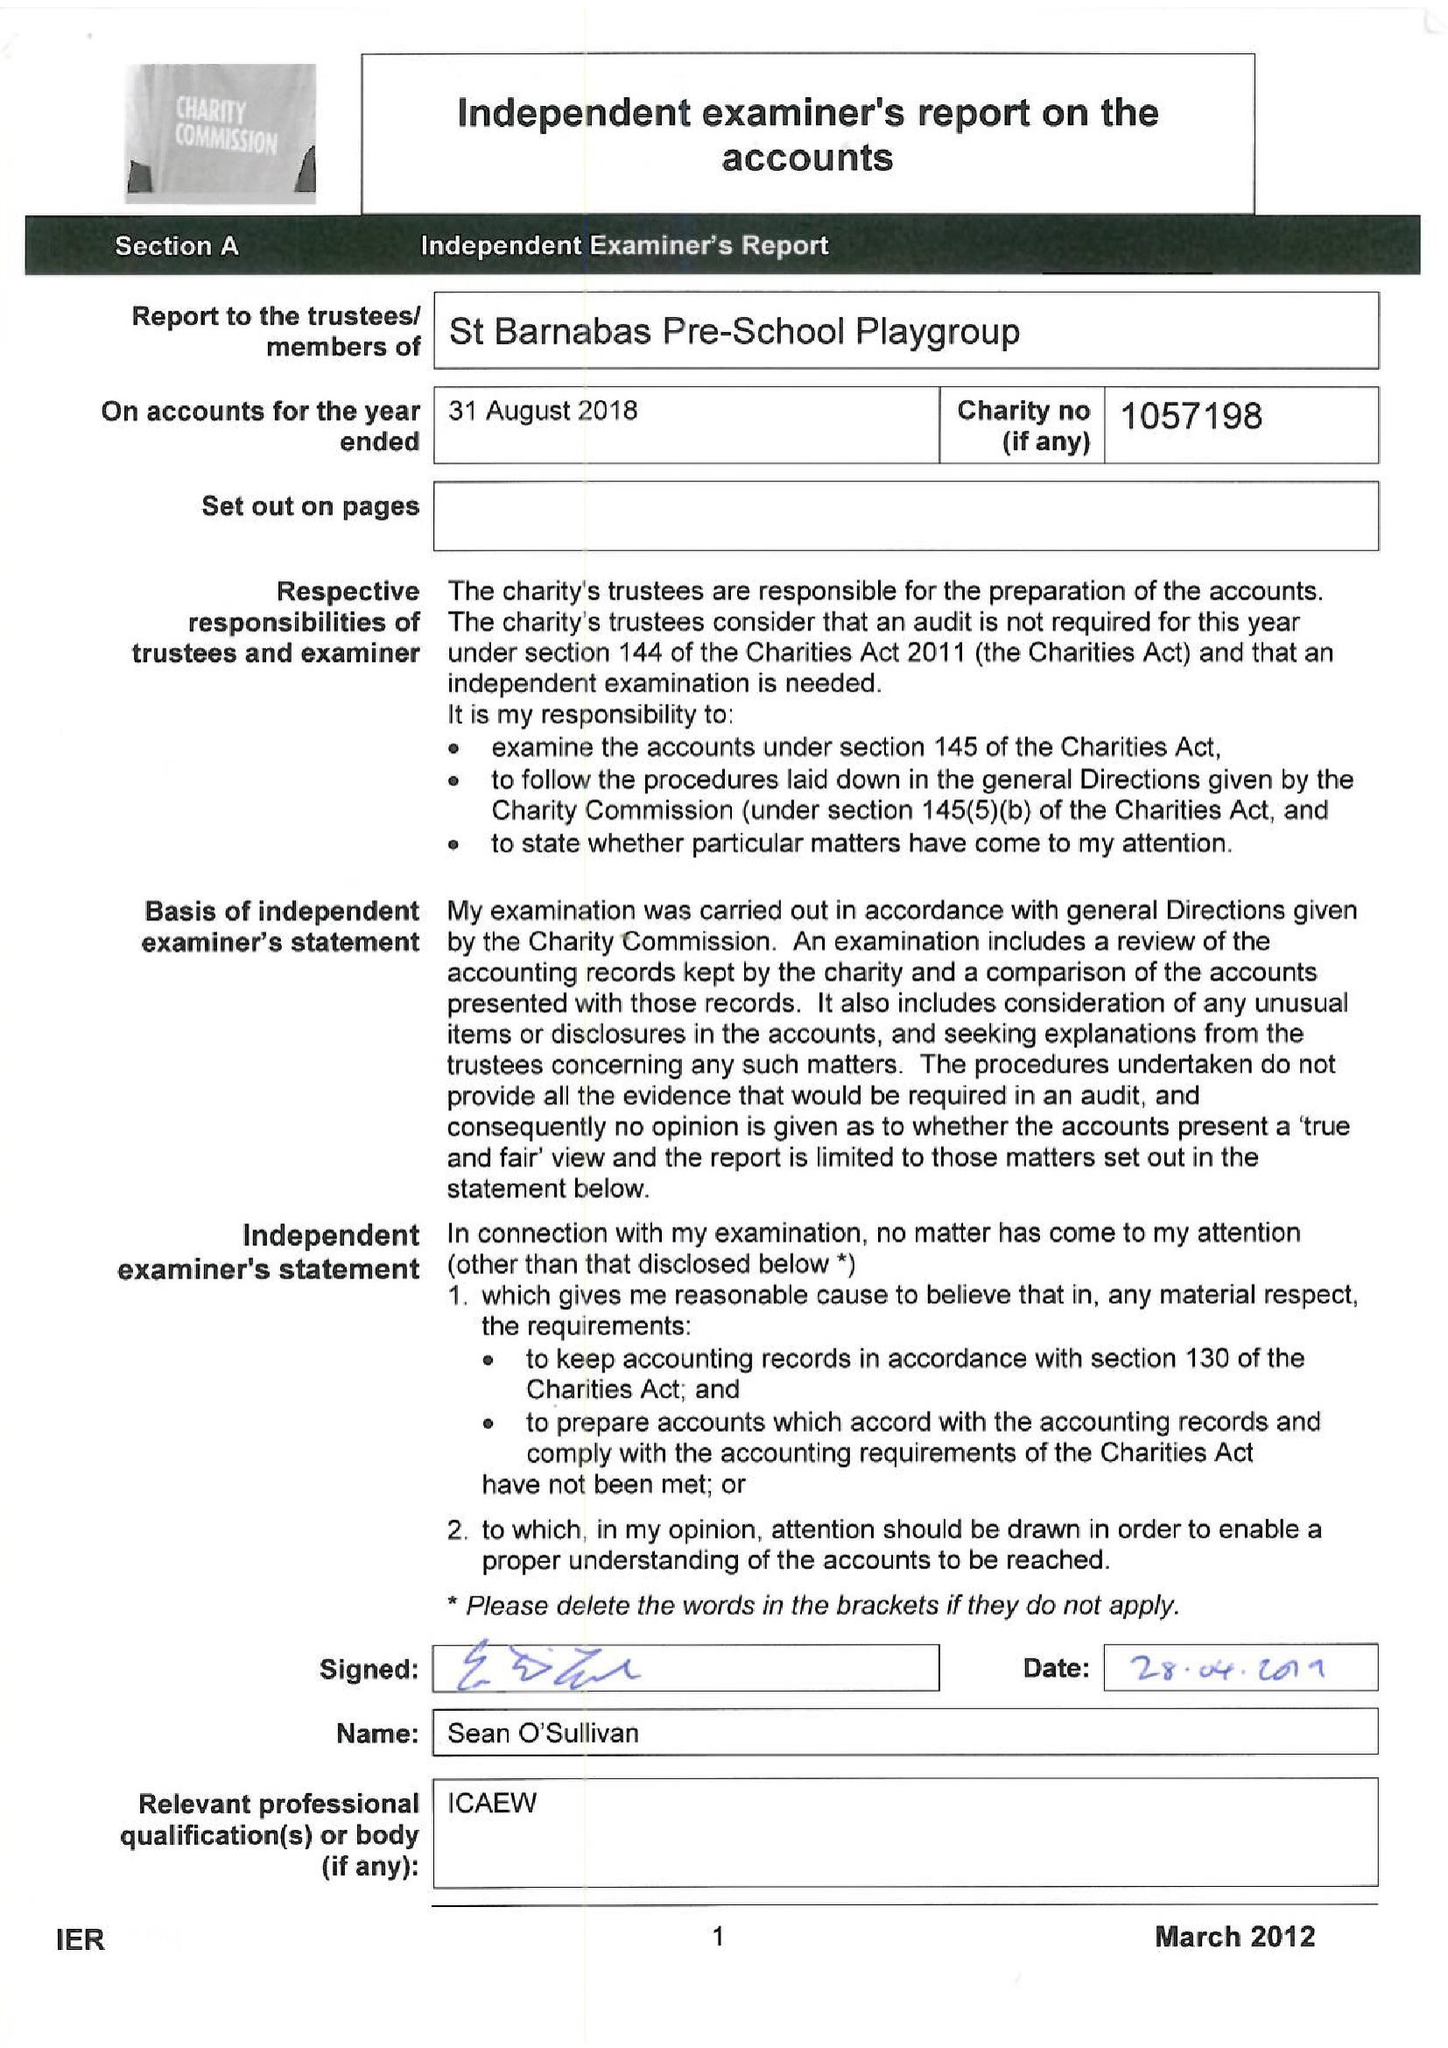What is the value for the income_annually_in_british_pounds?
Answer the question using a single word or phrase. 58630.00 